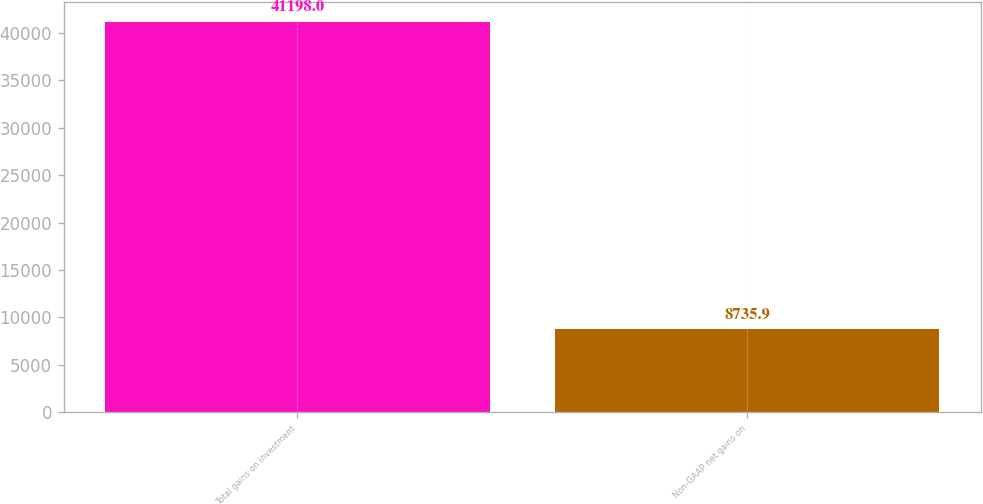Convert chart. <chart><loc_0><loc_0><loc_500><loc_500><bar_chart><fcel>Total gains on investment<fcel>Non-GAAP net gains on<nl><fcel>41198<fcel>8735.9<nl></chart> 